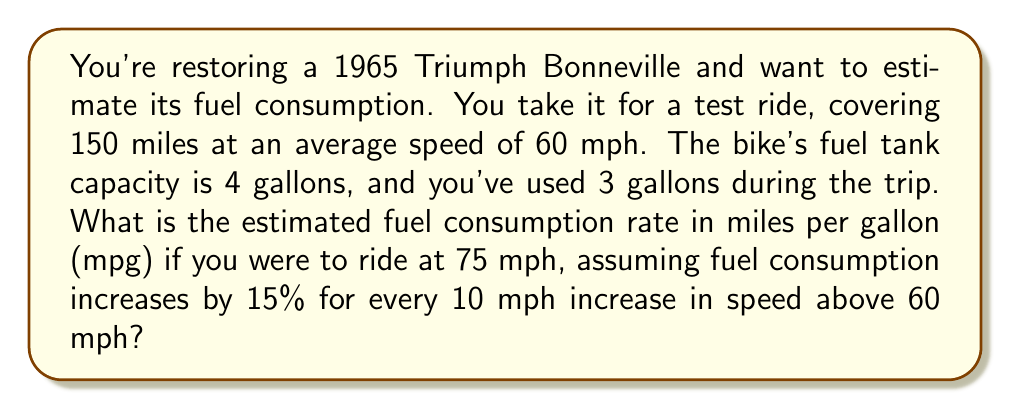What is the answer to this math problem? Let's approach this step-by-step:

1. Calculate the current fuel consumption rate:
   $$ \text{Current MPG} = \frac{\text{Distance traveled}}{\text{Fuel used}} = \frac{150 \text{ miles}}{3 \text{ gallons}} = 50 \text{ mpg} $$

2. Determine the speed increase:
   $$ \text{Speed increase} = 75 \text{ mph} - 60 \text{ mph} = 15 \text{ mph} $$

3. Calculate the percentage increase in fuel consumption:
   $$ \text{Percentage increase} = 15\% \times \frac{15 \text{ mph}}{10 \text{ mph}} = 22.5\% $$

4. Convert the percentage increase to a multiplier:
   $$ \text{Multiplier} = 1 + 0.225 = 1.225 $$

5. Calculate the new fuel consumption rate:
   $$ \text{New MPG} = \frac{\text{Current MPG}}{\text{Multiplier}} = \frac{50 \text{ mpg}}{1.225} \approx 40.82 \text{ mpg} $$
Answer: 40.82 mpg 